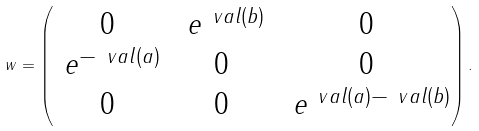<formula> <loc_0><loc_0><loc_500><loc_500>\ w = \begin{pmatrix} 0 & \ e ^ { \ v a l ( b ) } & 0 \\ \ e ^ { - \ v a l ( a ) } & 0 & 0 \\ 0 & 0 & \ e ^ { \ v a l ( a ) - \ v a l ( b ) } \end{pmatrix} .</formula> 